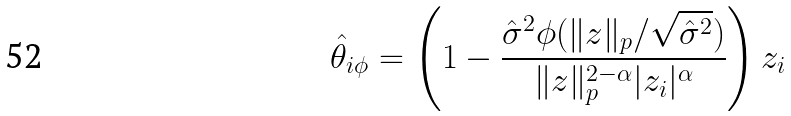Convert formula to latex. <formula><loc_0><loc_0><loc_500><loc_500>\hat { \theta } _ { i \phi } = \left ( 1 - \frac { \hat { \sigma } ^ { 2 } \phi ( \| z \| _ { p } / \sqrt { \hat { \sigma } ^ { 2 } } ) } { \| z \| _ { p } ^ { 2 - \alpha } | z _ { i } | ^ { \alpha } } \right ) z _ { i }</formula> 